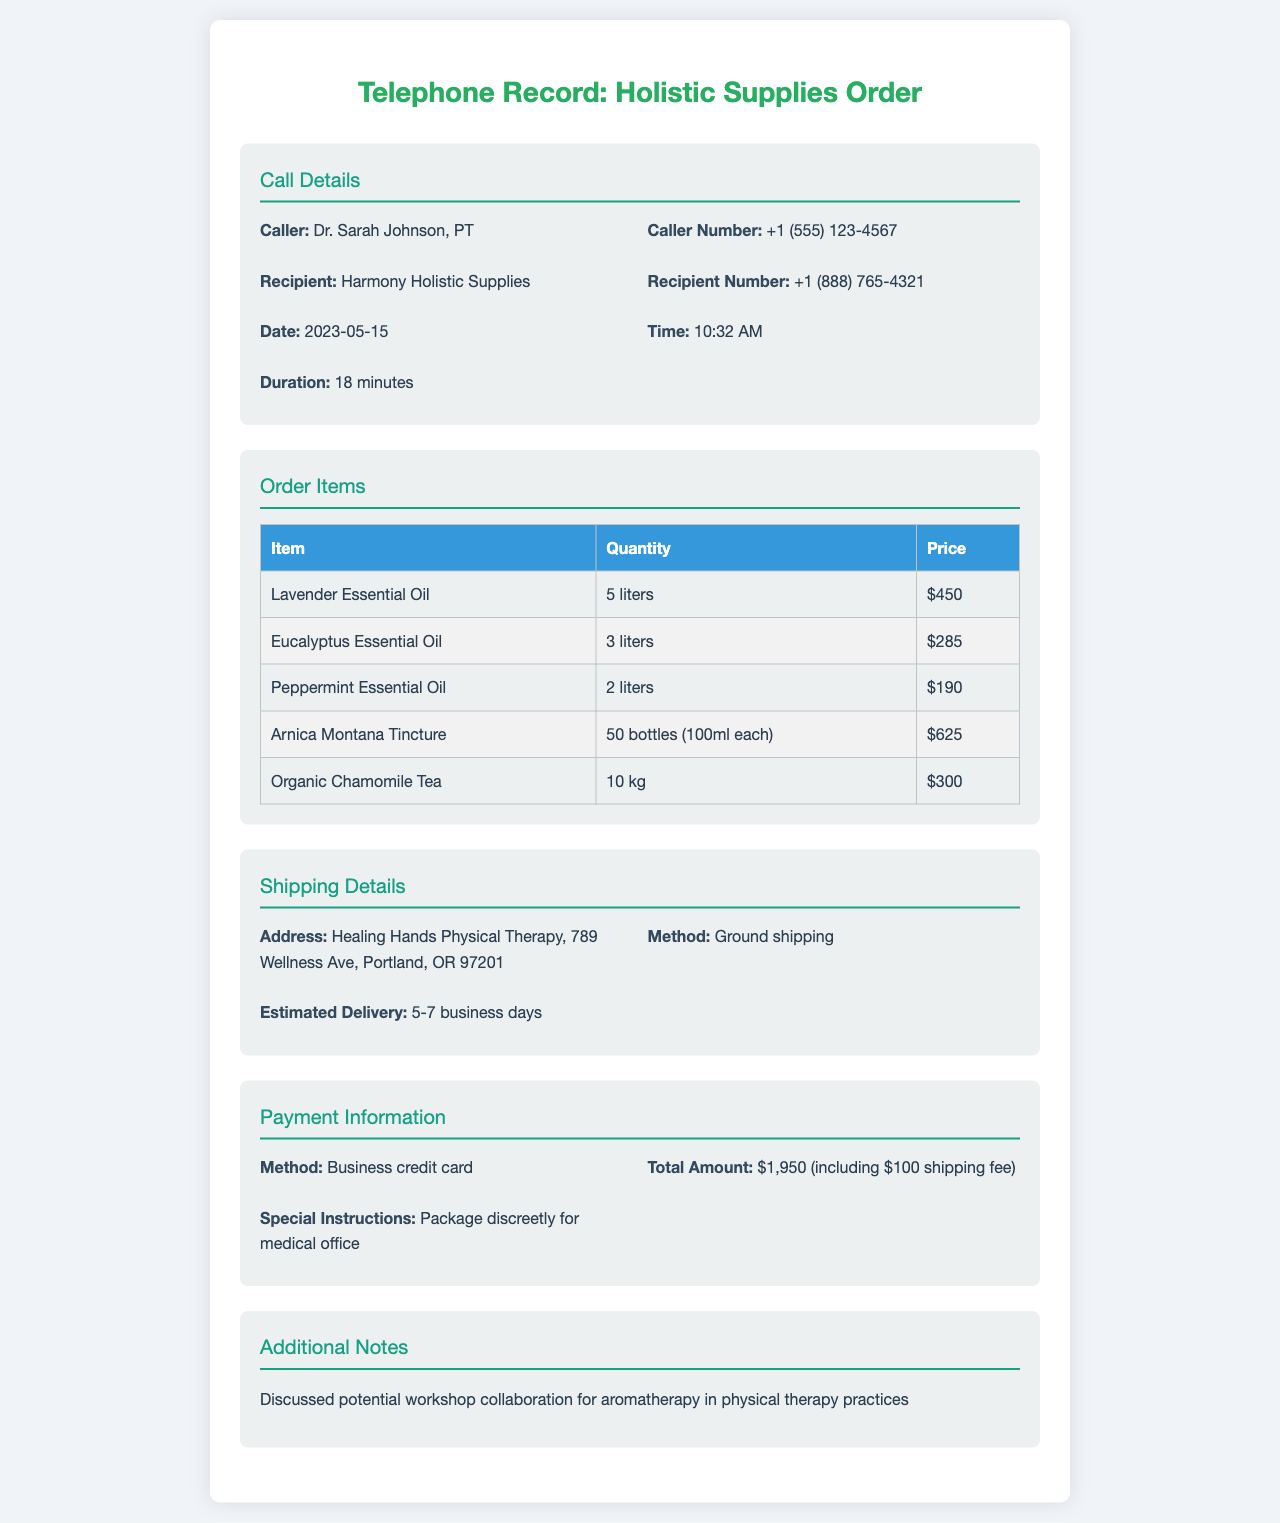What is the name of the caller? The document identifies the caller as "Dr. Sarah Johnson, PT".
Answer: Dr. Sarah Johnson, PT What is the total amount for the order? The document states the total amount as "$1,950 (including $100 shipping fee)".
Answer: $1,950 (including $100 shipping fee) How long did the call last? The call duration listed in the document is "18 minutes".
Answer: 18 minutes What is the delivery method for the order? The document indicates that the delivery method is "Ground shipping".
Answer: Ground shipping What is the quantity of Lavender Essential Oil ordered? According to the order items, "5 liters" of Lavender Essential Oil were requested.
Answer: 5 liters What was discussed in the additional notes? The note mentions a discussion about a "potential workshop collaboration for aromatherapy in physical therapy practices".
Answer: potential workshop collaboration for aromatherapy in physical therapy practices What is the estimated delivery time for the order? The document specifies that the estimated delivery time is "5-7 business days".
Answer: 5-7 business days Who is the recipient of the call? The recipient of the call is "Harmony Holistic Supplies".
Answer: Harmony Holistic Supplies How many bottles of Arnica Montana Tincture were ordered? The order specifies "50 bottles (100ml each)" of Arnica Montana Tincture.
Answer: 50 bottles (100ml each) 